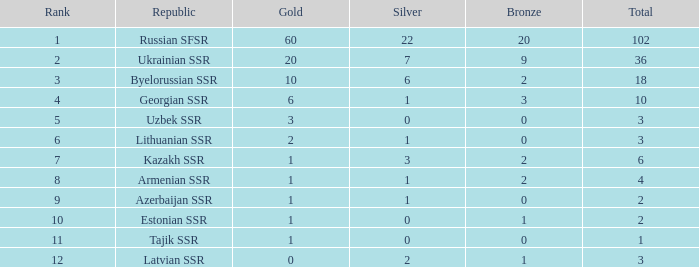Among teams in the 7th position with one or more silver medals, what is the highest count of bronze medals? 2.0. 